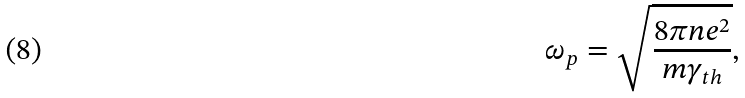<formula> <loc_0><loc_0><loc_500><loc_500>\omega _ { p } = \sqrt { \frac { 8 \pi n e ^ { 2 } } { m \gamma _ { t h } } } ,</formula> 